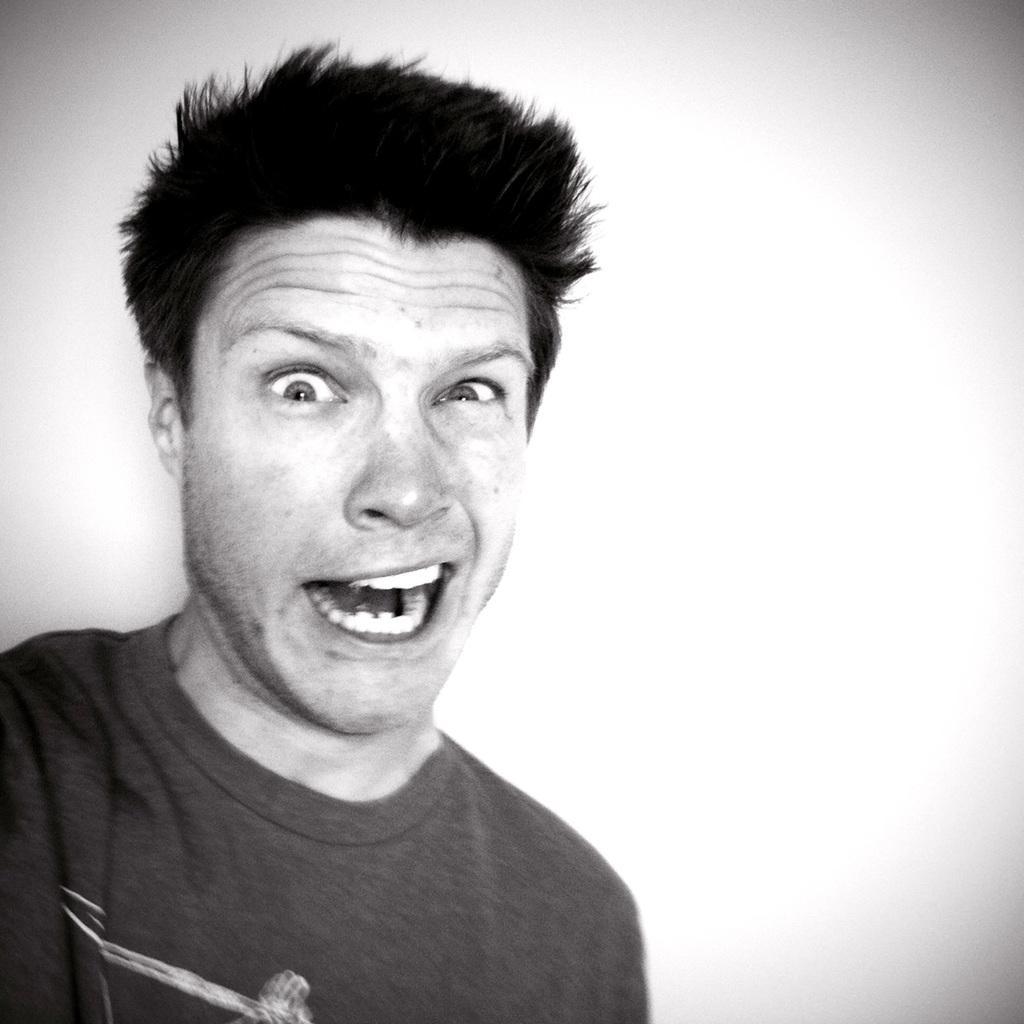Could you give a brief overview of what you see in this image? In this image we can see a person. The background of the image is white. 